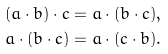<formula> <loc_0><loc_0><loc_500><loc_500>( a \cdot b ) \cdot c = a \cdot ( b \cdot c ) , \\ a \cdot ( b \cdot c ) = a \cdot ( c \cdot b ) .</formula> 